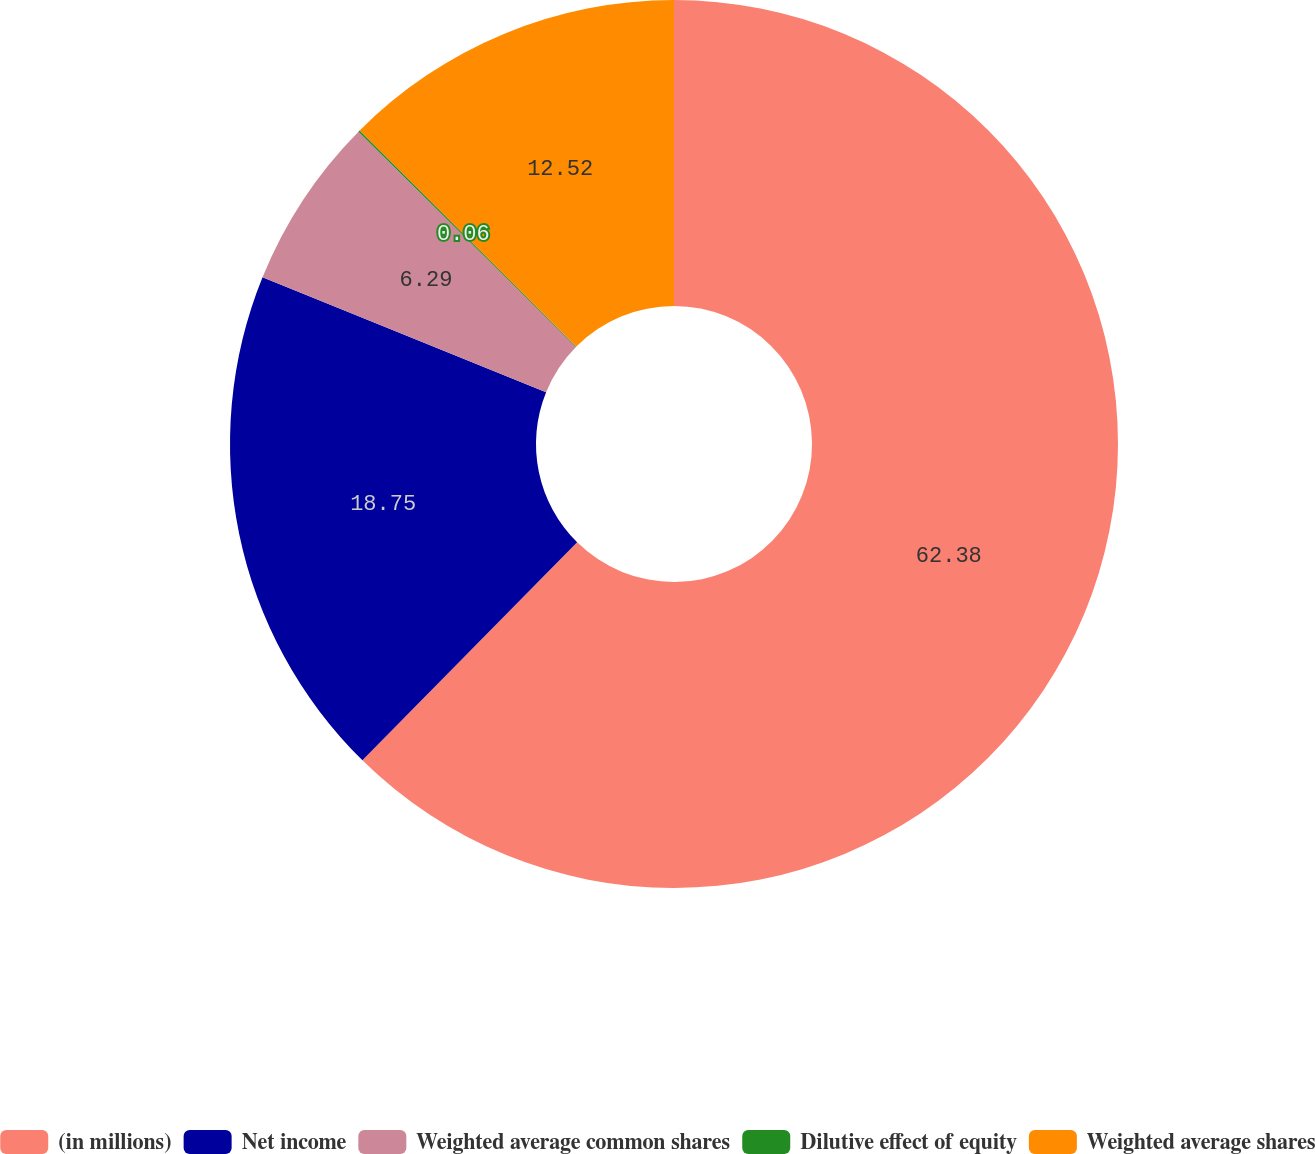<chart> <loc_0><loc_0><loc_500><loc_500><pie_chart><fcel>(in millions)<fcel>Net income<fcel>Weighted average common shares<fcel>Dilutive effect of equity<fcel>Weighted average shares<nl><fcel>62.38%<fcel>18.75%<fcel>6.29%<fcel>0.06%<fcel>12.52%<nl></chart> 